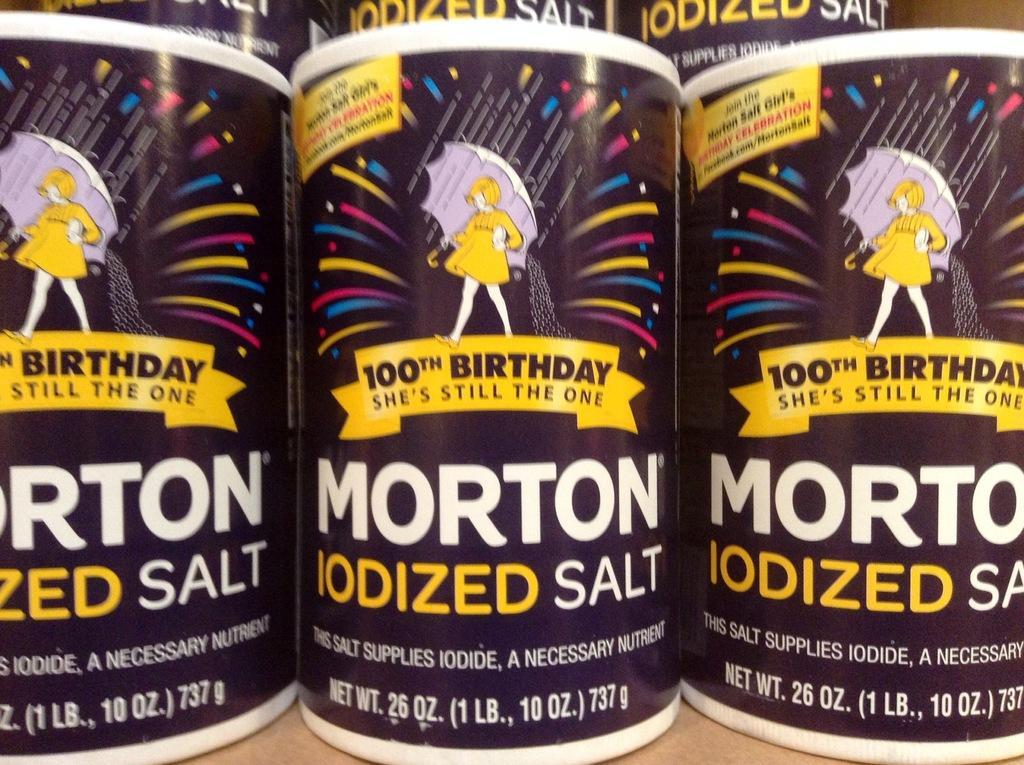In one or two sentences, can you explain what this image depicts? In this image I can see few boxes and I can see something written on the boxes and the boxes are in purple color and they are on the cream color surface. 